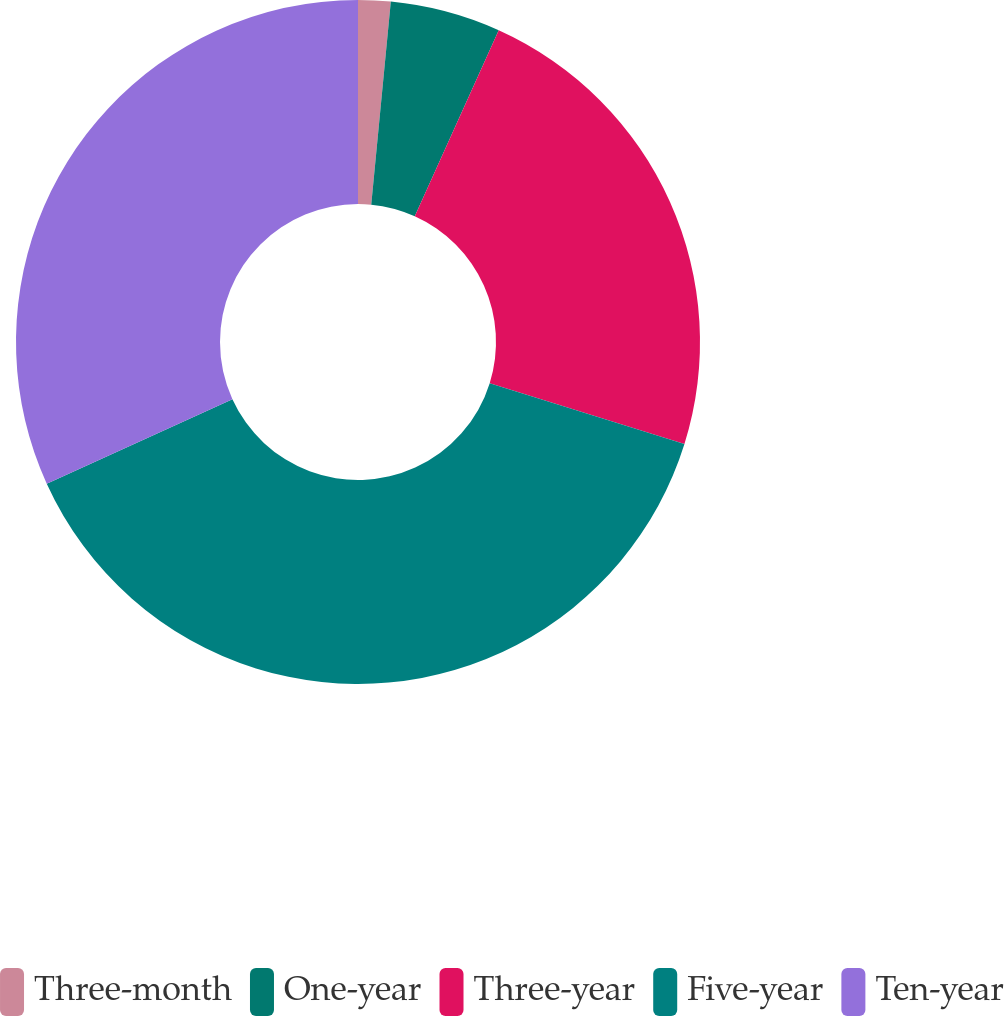Convert chart. <chart><loc_0><loc_0><loc_500><loc_500><pie_chart><fcel>Three-month<fcel>One-year<fcel>Three-year<fcel>Five-year<fcel>Ten-year<nl><fcel>1.53%<fcel>5.22%<fcel>23.07%<fcel>38.38%<fcel>31.8%<nl></chart> 